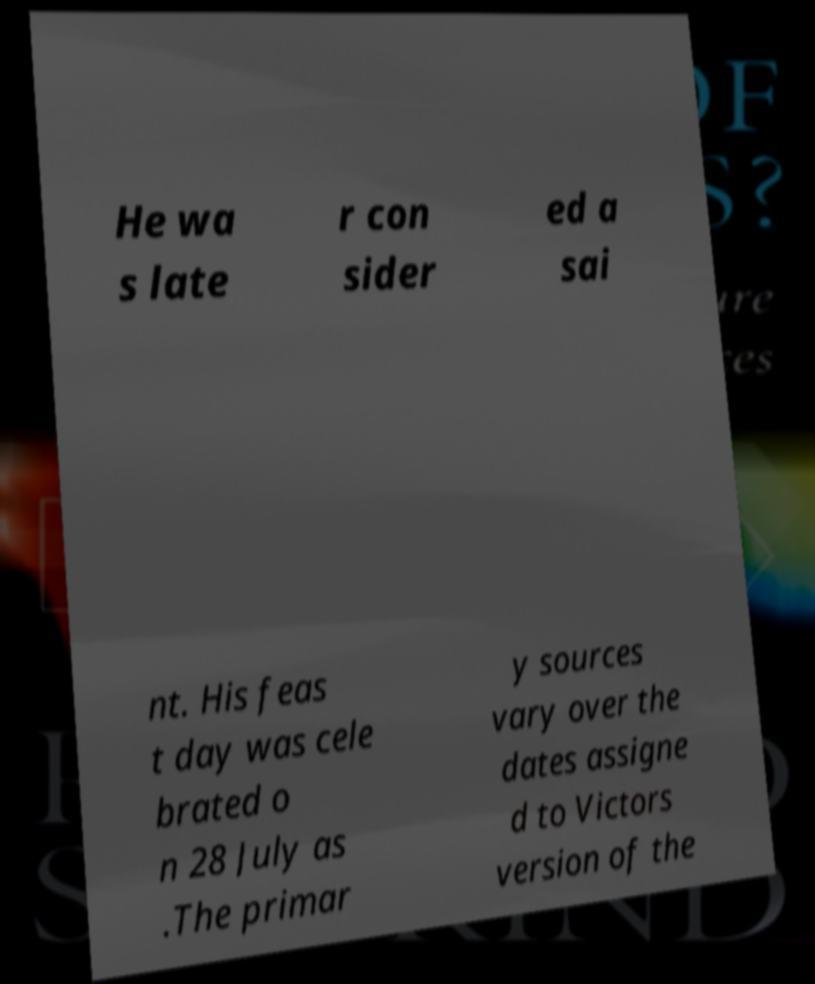Can you accurately transcribe the text from the provided image for me? He wa s late r con sider ed a sai nt. His feas t day was cele brated o n 28 July as .The primar y sources vary over the dates assigne d to Victors version of the 